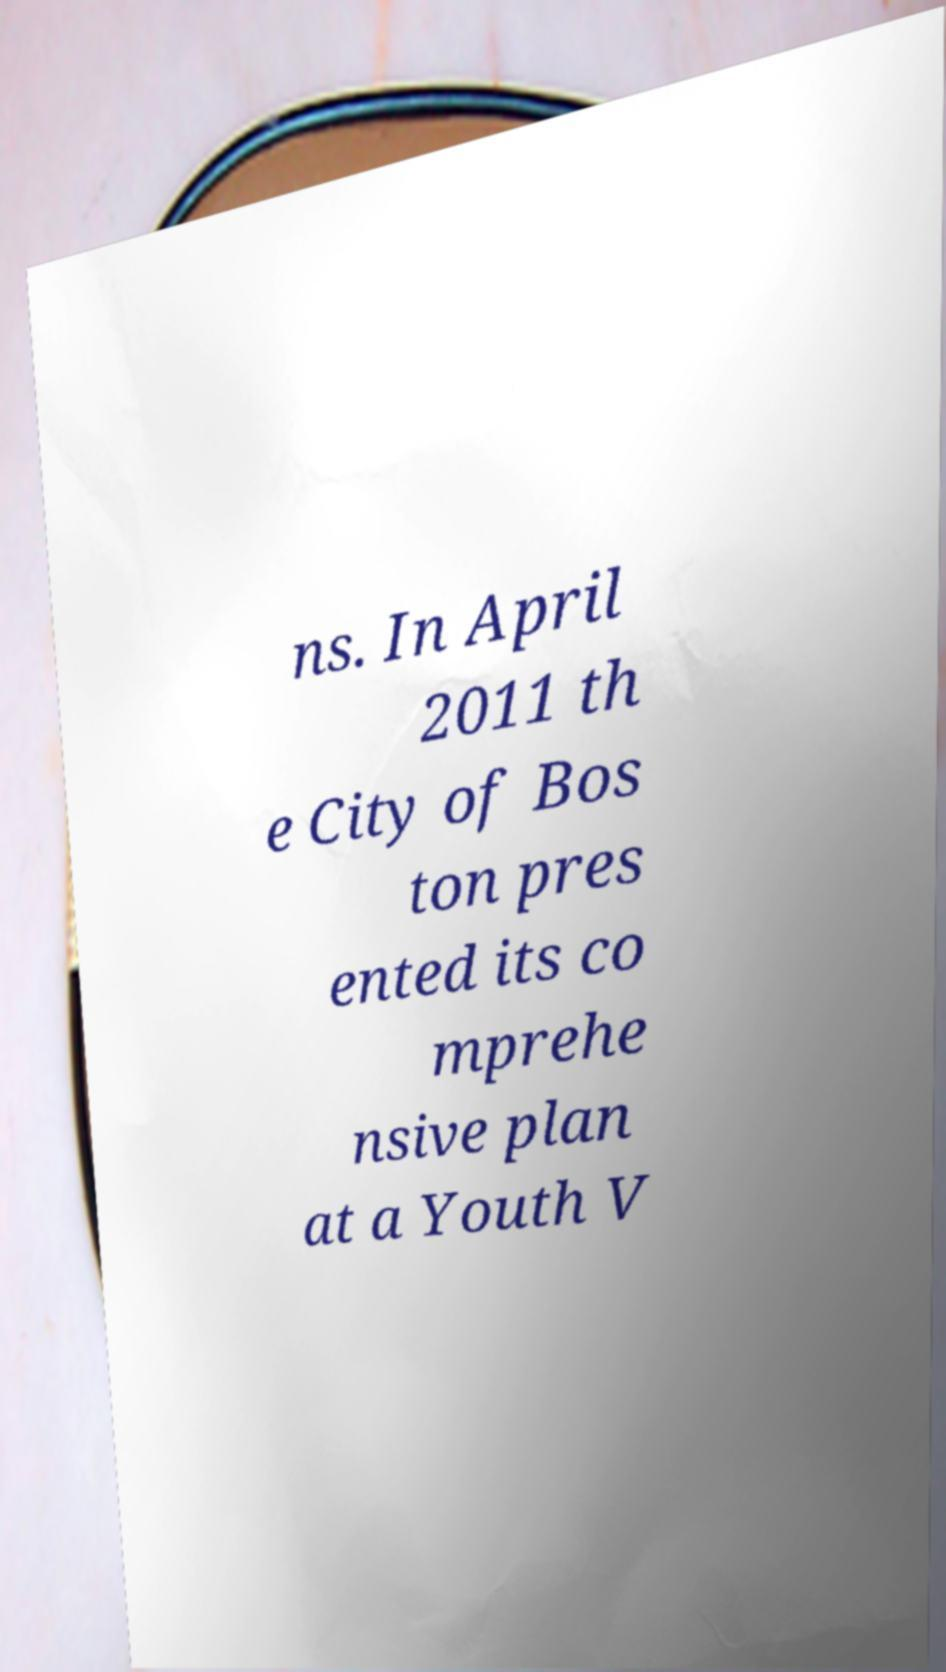For documentation purposes, I need the text within this image transcribed. Could you provide that? ns. In April 2011 th e City of Bos ton pres ented its co mprehe nsive plan at a Youth V 